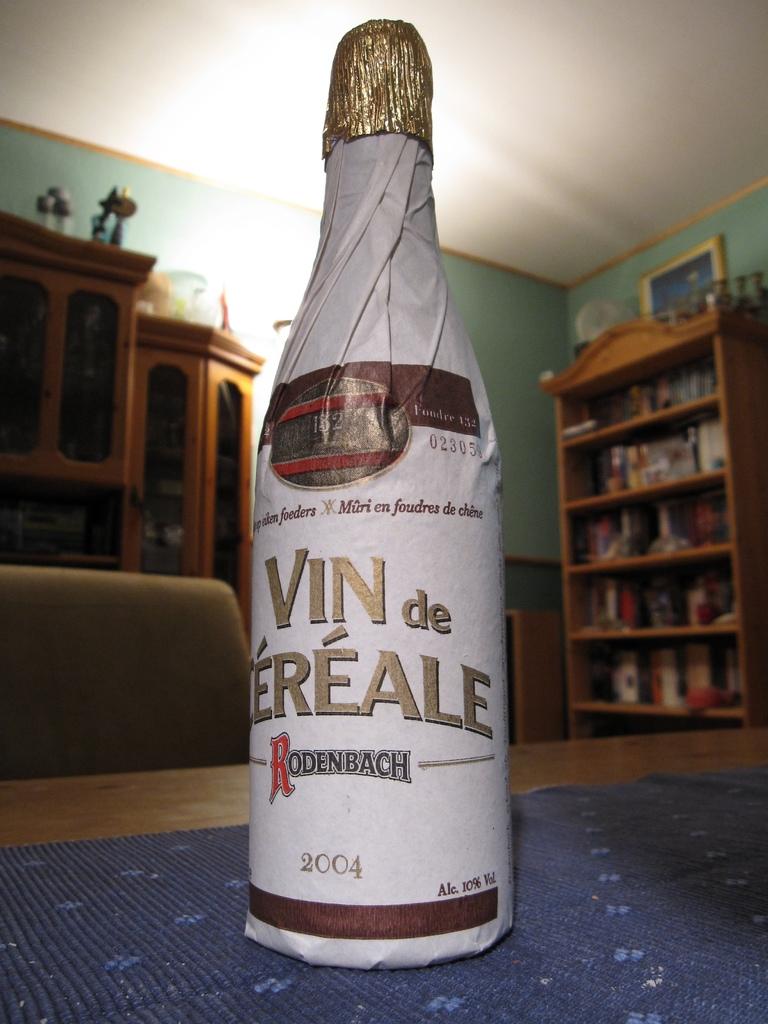What year is the beverage from?
Your answer should be compact. 2004. 